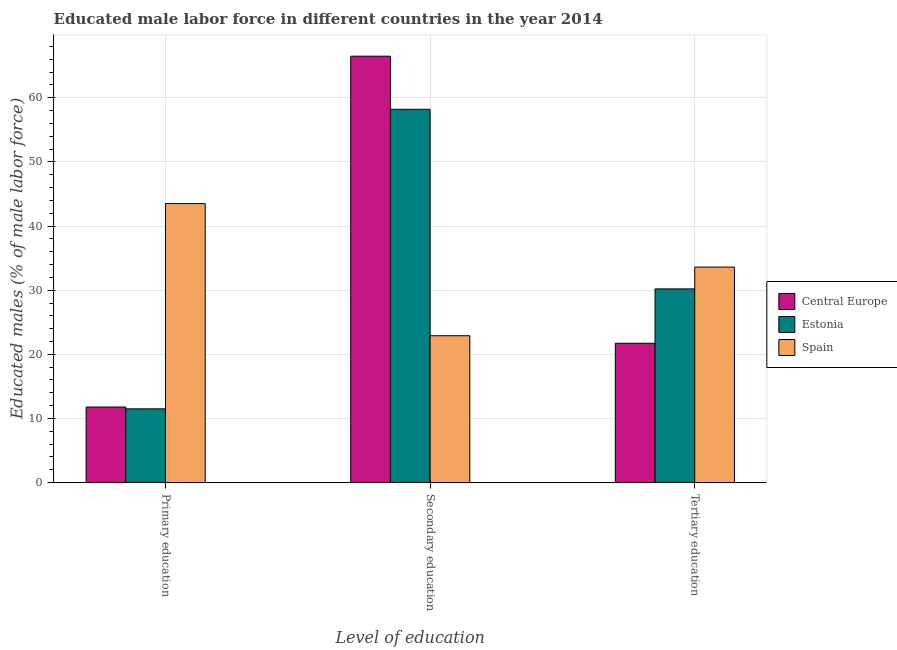How many different coloured bars are there?
Provide a succinct answer. 3. How many groups of bars are there?
Give a very brief answer. 3. Are the number of bars on each tick of the X-axis equal?
Your answer should be very brief. Yes. How many bars are there on the 3rd tick from the right?
Offer a very short reply. 3. What is the percentage of male labor force who received tertiary education in Central Europe?
Your response must be concise. 21.73. Across all countries, what is the maximum percentage of male labor force who received secondary education?
Offer a terse response. 66.48. Across all countries, what is the minimum percentage of male labor force who received secondary education?
Offer a terse response. 22.9. In which country was the percentage of male labor force who received tertiary education minimum?
Make the answer very short. Central Europe. What is the total percentage of male labor force who received secondary education in the graph?
Keep it short and to the point. 147.58. What is the difference between the percentage of male labor force who received secondary education in Estonia and that in Spain?
Your answer should be very brief. 35.3. What is the difference between the percentage of male labor force who received primary education in Spain and the percentage of male labor force who received secondary education in Estonia?
Provide a succinct answer. -14.7. What is the average percentage of male labor force who received secondary education per country?
Your response must be concise. 49.19. What is the difference between the percentage of male labor force who received secondary education and percentage of male labor force who received primary education in Spain?
Offer a very short reply. -20.6. What is the ratio of the percentage of male labor force who received tertiary education in Estonia to that in Central Europe?
Give a very brief answer. 1.39. Is the percentage of male labor force who received tertiary education in Central Europe less than that in Spain?
Make the answer very short. Yes. Is the difference between the percentage of male labor force who received primary education in Central Europe and Spain greater than the difference between the percentage of male labor force who received secondary education in Central Europe and Spain?
Keep it short and to the point. No. What is the difference between the highest and the second highest percentage of male labor force who received primary education?
Provide a succinct answer. 31.71. What is the difference between the highest and the lowest percentage of male labor force who received tertiary education?
Keep it short and to the point. 11.87. In how many countries, is the percentage of male labor force who received primary education greater than the average percentage of male labor force who received primary education taken over all countries?
Offer a terse response. 1. What does the 1st bar from the left in Primary education represents?
Make the answer very short. Central Europe. What does the 1st bar from the right in Tertiary education represents?
Ensure brevity in your answer.  Spain. How many bars are there?
Offer a very short reply. 9. Are all the bars in the graph horizontal?
Provide a succinct answer. No. What is the difference between two consecutive major ticks on the Y-axis?
Offer a terse response. 10. Are the values on the major ticks of Y-axis written in scientific E-notation?
Your answer should be very brief. No. Does the graph contain any zero values?
Offer a terse response. No. Where does the legend appear in the graph?
Give a very brief answer. Center right. What is the title of the graph?
Your answer should be compact. Educated male labor force in different countries in the year 2014. What is the label or title of the X-axis?
Provide a succinct answer. Level of education. What is the label or title of the Y-axis?
Give a very brief answer. Educated males (% of male labor force). What is the Educated males (% of male labor force) of Central Europe in Primary education?
Keep it short and to the point. 11.79. What is the Educated males (% of male labor force) of Spain in Primary education?
Give a very brief answer. 43.5. What is the Educated males (% of male labor force) in Central Europe in Secondary education?
Offer a very short reply. 66.48. What is the Educated males (% of male labor force) in Estonia in Secondary education?
Keep it short and to the point. 58.2. What is the Educated males (% of male labor force) of Spain in Secondary education?
Provide a short and direct response. 22.9. What is the Educated males (% of male labor force) of Central Europe in Tertiary education?
Your response must be concise. 21.73. What is the Educated males (% of male labor force) of Estonia in Tertiary education?
Your answer should be compact. 30.2. What is the Educated males (% of male labor force) of Spain in Tertiary education?
Offer a very short reply. 33.6. Across all Level of education, what is the maximum Educated males (% of male labor force) of Central Europe?
Offer a very short reply. 66.48. Across all Level of education, what is the maximum Educated males (% of male labor force) of Estonia?
Keep it short and to the point. 58.2. Across all Level of education, what is the maximum Educated males (% of male labor force) in Spain?
Your answer should be compact. 43.5. Across all Level of education, what is the minimum Educated males (% of male labor force) of Central Europe?
Keep it short and to the point. 11.79. Across all Level of education, what is the minimum Educated males (% of male labor force) of Estonia?
Keep it short and to the point. 11.5. Across all Level of education, what is the minimum Educated males (% of male labor force) of Spain?
Offer a very short reply. 22.9. What is the total Educated males (% of male labor force) of Central Europe in the graph?
Give a very brief answer. 99.99. What is the total Educated males (% of male labor force) in Estonia in the graph?
Provide a succinct answer. 99.9. What is the difference between the Educated males (% of male labor force) in Central Europe in Primary education and that in Secondary education?
Provide a short and direct response. -54.69. What is the difference between the Educated males (% of male labor force) in Estonia in Primary education and that in Secondary education?
Give a very brief answer. -46.7. What is the difference between the Educated males (% of male labor force) in Spain in Primary education and that in Secondary education?
Ensure brevity in your answer.  20.6. What is the difference between the Educated males (% of male labor force) of Central Europe in Primary education and that in Tertiary education?
Your answer should be compact. -9.94. What is the difference between the Educated males (% of male labor force) in Estonia in Primary education and that in Tertiary education?
Give a very brief answer. -18.7. What is the difference between the Educated males (% of male labor force) in Central Europe in Secondary education and that in Tertiary education?
Ensure brevity in your answer.  44.75. What is the difference between the Educated males (% of male labor force) of Estonia in Secondary education and that in Tertiary education?
Provide a short and direct response. 28. What is the difference between the Educated males (% of male labor force) of Central Europe in Primary education and the Educated males (% of male labor force) of Estonia in Secondary education?
Make the answer very short. -46.41. What is the difference between the Educated males (% of male labor force) of Central Europe in Primary education and the Educated males (% of male labor force) of Spain in Secondary education?
Give a very brief answer. -11.11. What is the difference between the Educated males (% of male labor force) of Central Europe in Primary education and the Educated males (% of male labor force) of Estonia in Tertiary education?
Offer a terse response. -18.41. What is the difference between the Educated males (% of male labor force) in Central Europe in Primary education and the Educated males (% of male labor force) in Spain in Tertiary education?
Offer a terse response. -21.81. What is the difference between the Educated males (% of male labor force) of Estonia in Primary education and the Educated males (% of male labor force) of Spain in Tertiary education?
Offer a terse response. -22.1. What is the difference between the Educated males (% of male labor force) of Central Europe in Secondary education and the Educated males (% of male labor force) of Estonia in Tertiary education?
Provide a succinct answer. 36.28. What is the difference between the Educated males (% of male labor force) of Central Europe in Secondary education and the Educated males (% of male labor force) of Spain in Tertiary education?
Your response must be concise. 32.88. What is the difference between the Educated males (% of male labor force) in Estonia in Secondary education and the Educated males (% of male labor force) in Spain in Tertiary education?
Keep it short and to the point. 24.6. What is the average Educated males (% of male labor force) in Central Europe per Level of education?
Your answer should be very brief. 33.33. What is the average Educated males (% of male labor force) of Estonia per Level of education?
Your answer should be compact. 33.3. What is the average Educated males (% of male labor force) in Spain per Level of education?
Give a very brief answer. 33.33. What is the difference between the Educated males (% of male labor force) of Central Europe and Educated males (% of male labor force) of Estonia in Primary education?
Provide a short and direct response. 0.29. What is the difference between the Educated males (% of male labor force) of Central Europe and Educated males (% of male labor force) of Spain in Primary education?
Your answer should be very brief. -31.71. What is the difference between the Educated males (% of male labor force) in Estonia and Educated males (% of male labor force) in Spain in Primary education?
Provide a succinct answer. -32. What is the difference between the Educated males (% of male labor force) in Central Europe and Educated males (% of male labor force) in Estonia in Secondary education?
Offer a terse response. 8.28. What is the difference between the Educated males (% of male labor force) of Central Europe and Educated males (% of male labor force) of Spain in Secondary education?
Give a very brief answer. 43.58. What is the difference between the Educated males (% of male labor force) in Estonia and Educated males (% of male labor force) in Spain in Secondary education?
Provide a short and direct response. 35.3. What is the difference between the Educated males (% of male labor force) in Central Europe and Educated males (% of male labor force) in Estonia in Tertiary education?
Give a very brief answer. -8.47. What is the difference between the Educated males (% of male labor force) in Central Europe and Educated males (% of male labor force) in Spain in Tertiary education?
Provide a short and direct response. -11.87. What is the difference between the Educated males (% of male labor force) in Estonia and Educated males (% of male labor force) in Spain in Tertiary education?
Provide a short and direct response. -3.4. What is the ratio of the Educated males (% of male labor force) in Central Europe in Primary education to that in Secondary education?
Offer a very short reply. 0.18. What is the ratio of the Educated males (% of male labor force) of Estonia in Primary education to that in Secondary education?
Ensure brevity in your answer.  0.2. What is the ratio of the Educated males (% of male labor force) in Spain in Primary education to that in Secondary education?
Your response must be concise. 1.9. What is the ratio of the Educated males (% of male labor force) of Central Europe in Primary education to that in Tertiary education?
Your response must be concise. 0.54. What is the ratio of the Educated males (% of male labor force) in Estonia in Primary education to that in Tertiary education?
Provide a succinct answer. 0.38. What is the ratio of the Educated males (% of male labor force) in Spain in Primary education to that in Tertiary education?
Keep it short and to the point. 1.29. What is the ratio of the Educated males (% of male labor force) of Central Europe in Secondary education to that in Tertiary education?
Offer a very short reply. 3.06. What is the ratio of the Educated males (% of male labor force) of Estonia in Secondary education to that in Tertiary education?
Your response must be concise. 1.93. What is the ratio of the Educated males (% of male labor force) in Spain in Secondary education to that in Tertiary education?
Your response must be concise. 0.68. What is the difference between the highest and the second highest Educated males (% of male labor force) of Central Europe?
Offer a terse response. 44.75. What is the difference between the highest and the second highest Educated males (% of male labor force) of Estonia?
Keep it short and to the point. 28. What is the difference between the highest and the lowest Educated males (% of male labor force) in Central Europe?
Make the answer very short. 54.69. What is the difference between the highest and the lowest Educated males (% of male labor force) of Estonia?
Offer a very short reply. 46.7. What is the difference between the highest and the lowest Educated males (% of male labor force) of Spain?
Make the answer very short. 20.6. 